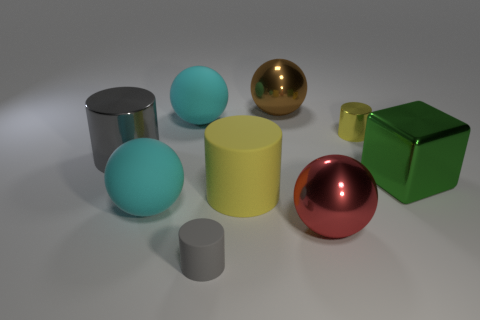Subtract all small gray rubber cylinders. How many cylinders are left? 3 Subtract all cyan balls. How many balls are left? 2 Subtract 3 cylinders. How many cylinders are left? 1 Subtract all purple cylinders. How many cyan spheres are left? 2 Subtract 1 yellow cylinders. How many objects are left? 8 Subtract all cylinders. How many objects are left? 5 Subtract all purple cylinders. Subtract all green cubes. How many cylinders are left? 4 Subtract all tiny brown metal spheres. Subtract all red shiny things. How many objects are left? 8 Add 5 metal cylinders. How many metal cylinders are left? 7 Add 6 big red metal blocks. How many big red metal blocks exist? 6 